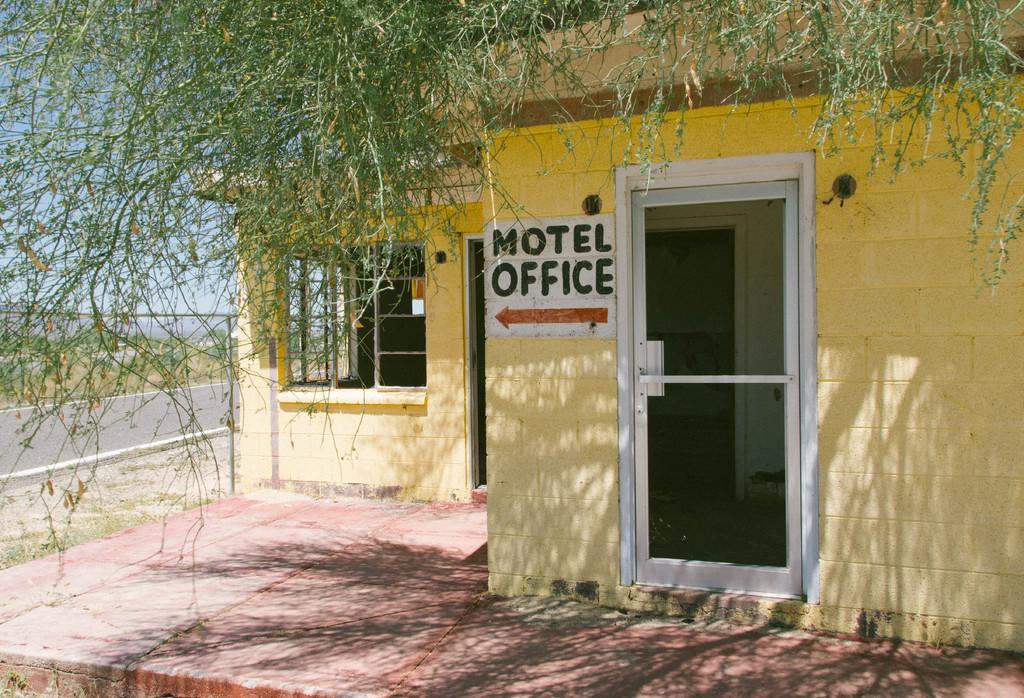In one or two sentences, can you explain what this image depicts? In the foreground of this image, there is a building. At the top, it seems like a tree. In the background, there is a road and the sky. 